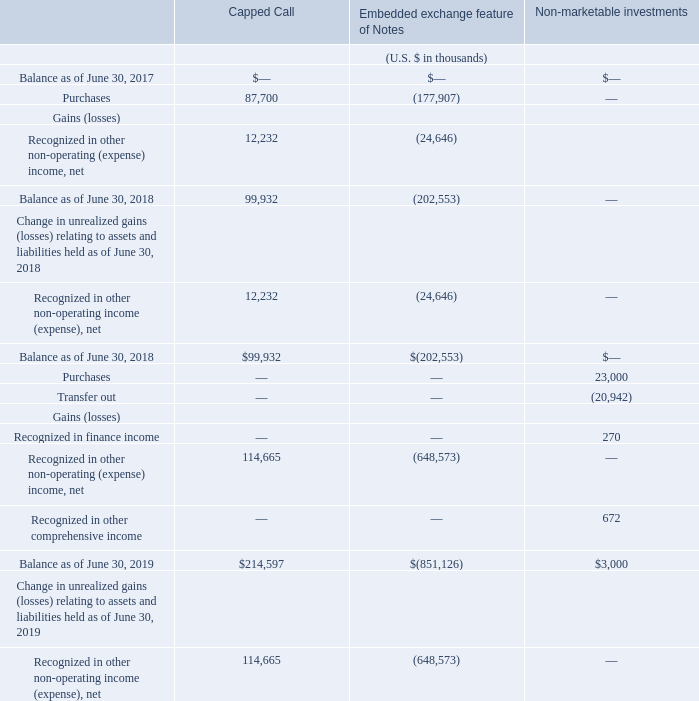Non-marketable investments
Non-marketable equity securities are measured at fair value using market data, such as publicly available financing round valuations. Financial information of private companies may not be available and consequently we will estimate the fair value based on the best available information at the measurement date.
The following table presents the reconciliations of Level 3 financial instrument fair values:
There were transfers out from Level 3 due to initial public offerings of the respective investees during fiscal year 2019. There were no transfers between levels during fiscal year 2018.
How are non-marketable equity securities measured? Using market data, such as publicly available financing round valuations. Why was there transfers out of Level 3 during fiscal year 2019? Due to initial public offerings of the respective investees. What is the balance of capped call as of June 30, 2019?
Answer scale should be: thousand. $214,597. What is the change in the balance of capped call between fiscal year ended June 30, 2018 and 2019?
Answer scale should be: thousand. 214,597-99,932
Answer: 114665. What is the percentage change in the balance of capped call between fiscal year ended June 30, 2018 and 2019?
Answer scale should be: percent. (214,597-99,932)/99,932
Answer: 114.74. What is the difference in balance of capped call and non-marketable investments as of June 30, 2019?
Answer scale should be: thousand. 214,597-3,000
Answer: 211597. 